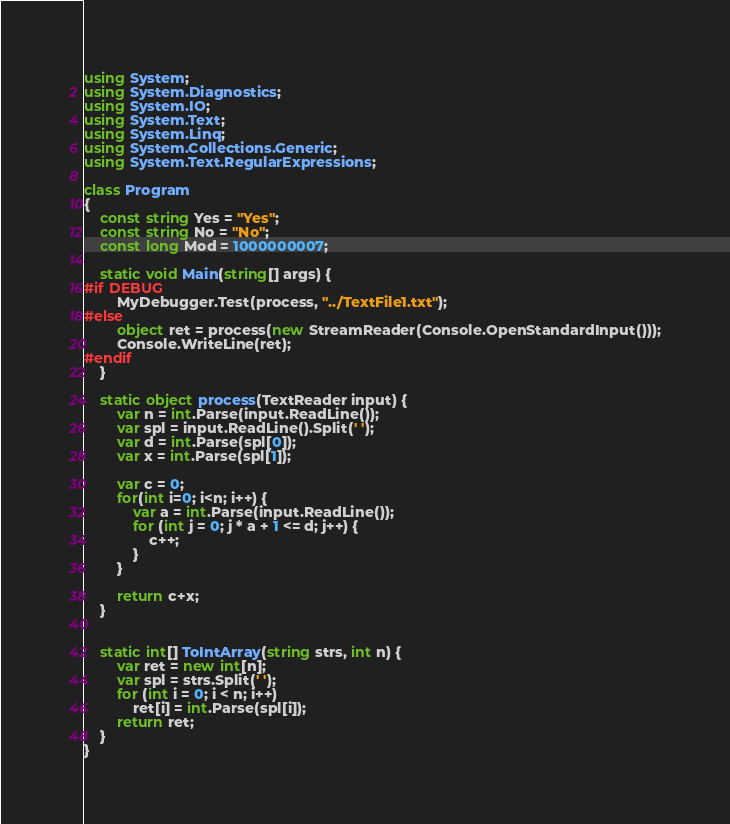<code> <loc_0><loc_0><loc_500><loc_500><_C#_>using System;
using System.Diagnostics;
using System.IO;
using System.Text;
using System.Linq;
using System.Collections.Generic;
using System.Text.RegularExpressions;

class Program
{
    const string Yes = "Yes";
    const string No = "No";
    const long Mod = 1000000007;

    static void Main(string[] args) {
#if DEBUG
        MyDebugger.Test(process, "../TextFile1.txt");
#else
        object ret = process(new StreamReader(Console.OpenStandardInput()));
        Console.WriteLine(ret);
#endif
    }

    static object process(TextReader input) {
        var n = int.Parse(input.ReadLine());
        var spl = input.ReadLine().Split(' ');
        var d = int.Parse(spl[0]);
        var x = int.Parse(spl[1]);

        var c = 0;
        for(int i=0; i<n; i++) {
            var a = int.Parse(input.ReadLine());
            for (int j = 0; j * a + 1 <= d; j++) {
                c++;
            }
        }

        return c+x;
    }


    static int[] ToIntArray(string strs, int n) {
        var ret = new int[n];
        var spl = strs.Split(' ');
        for (int i = 0; i < n; i++)
            ret[i] = int.Parse(spl[i]);
        return ret;
    }
}
</code> 